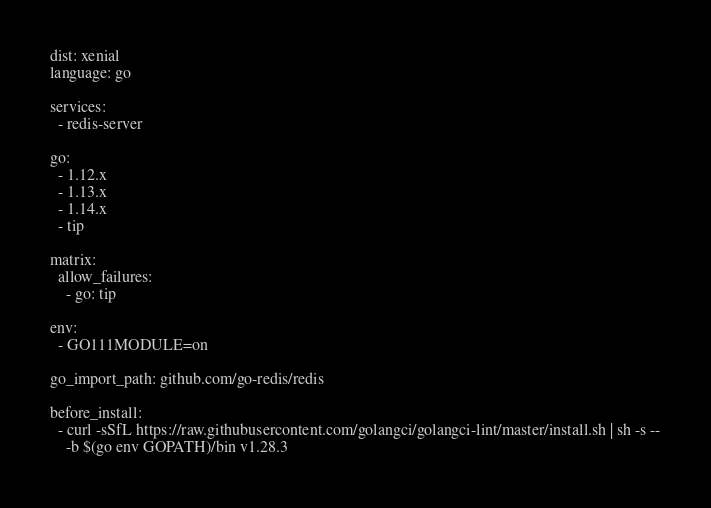<code> <loc_0><loc_0><loc_500><loc_500><_YAML_>dist: xenial
language: go

services:
  - redis-server

go:
  - 1.12.x
  - 1.13.x
  - 1.14.x
  - tip

matrix:
  allow_failures:
    - go: tip

env:
  - GO111MODULE=on

go_import_path: github.com/go-redis/redis

before_install:
  - curl -sSfL https://raw.githubusercontent.com/golangci/golangci-lint/master/install.sh | sh -s --
    -b $(go env GOPATH)/bin v1.28.3
</code> 